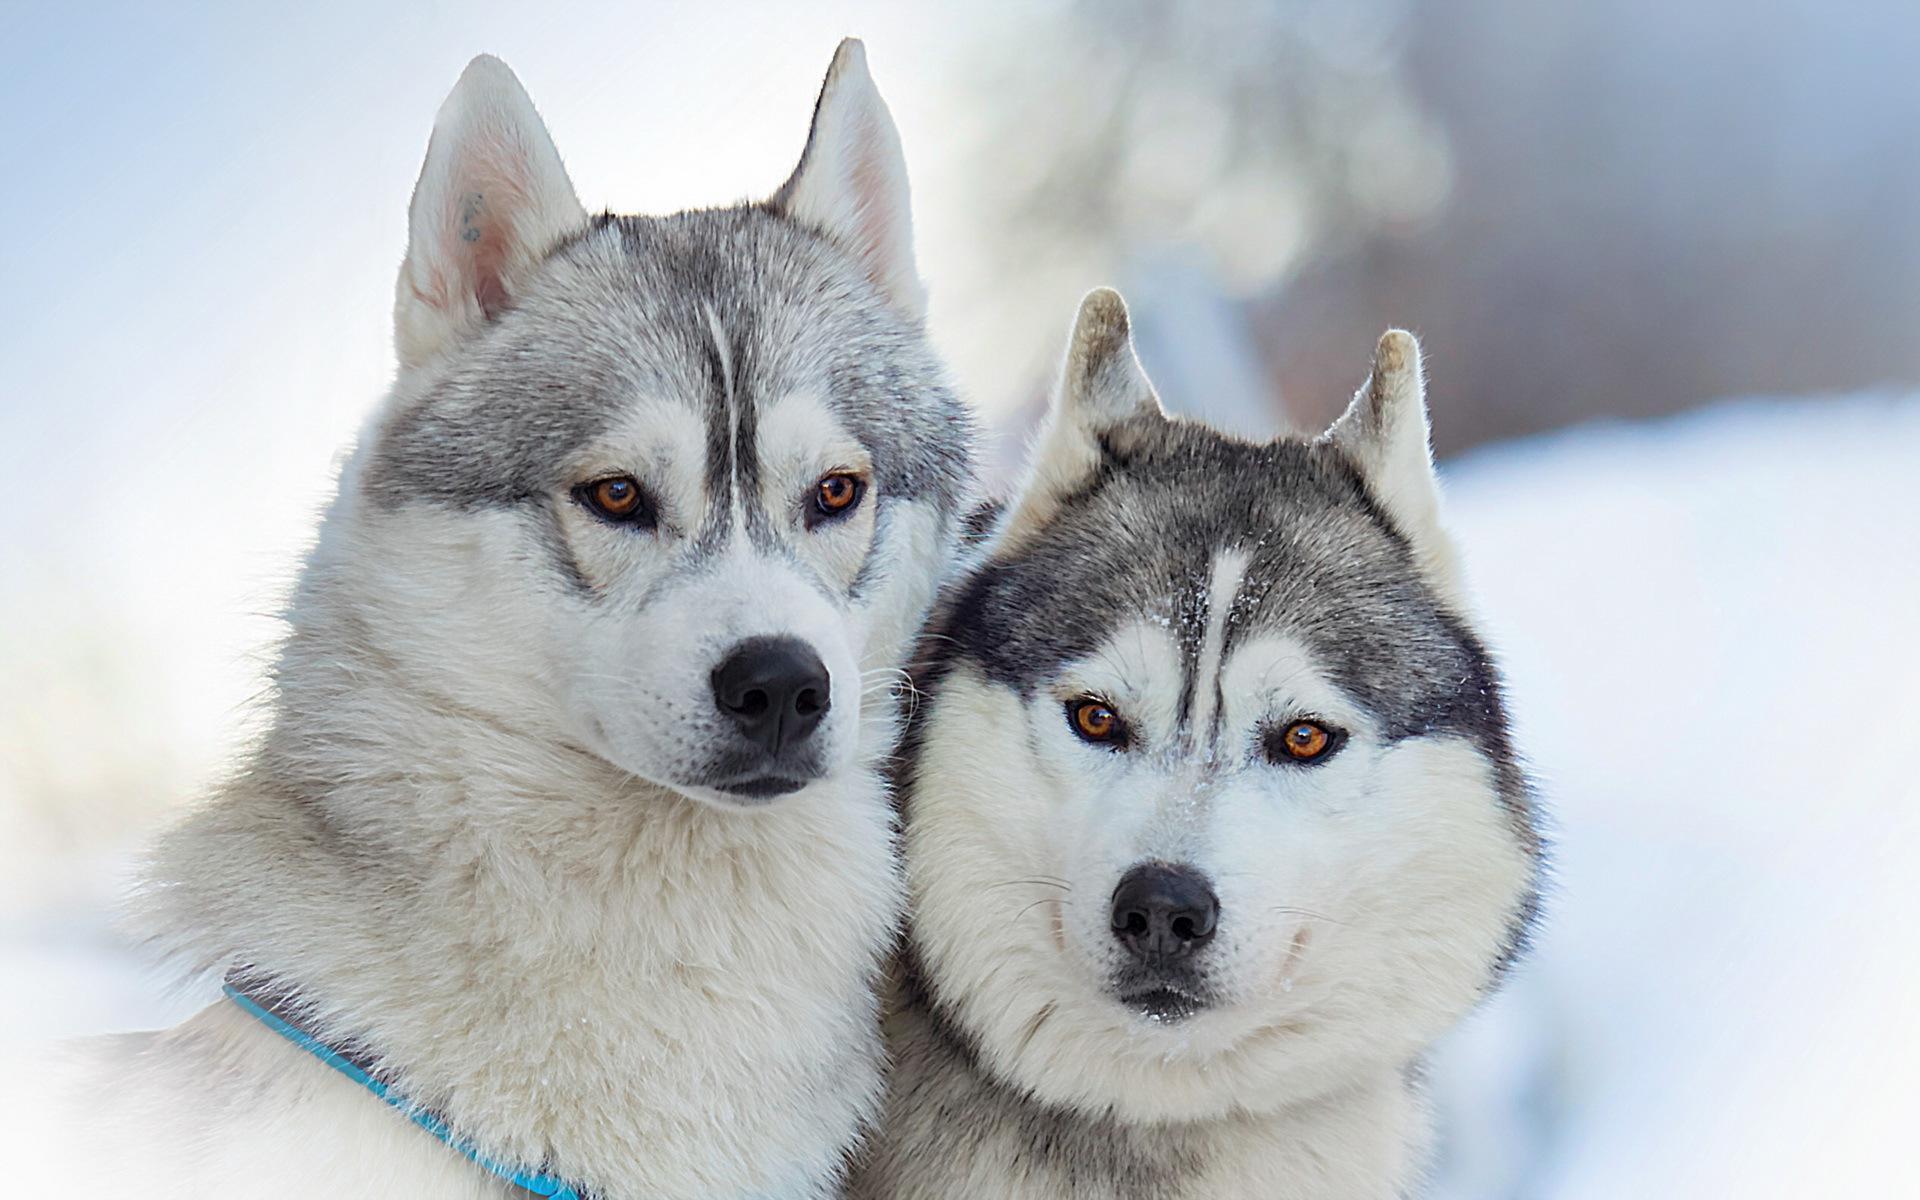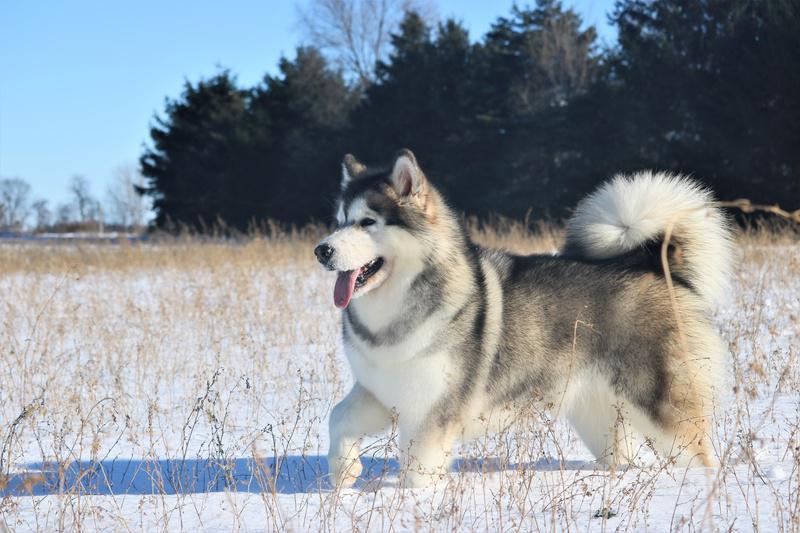The first image is the image on the left, the second image is the image on the right. For the images shown, is this caption "There are three dogs." true? Answer yes or no. Yes. The first image is the image on the left, the second image is the image on the right. Analyze the images presented: Is the assertion "The left and right image contains the same number of dogs." valid? Answer yes or no. No. 